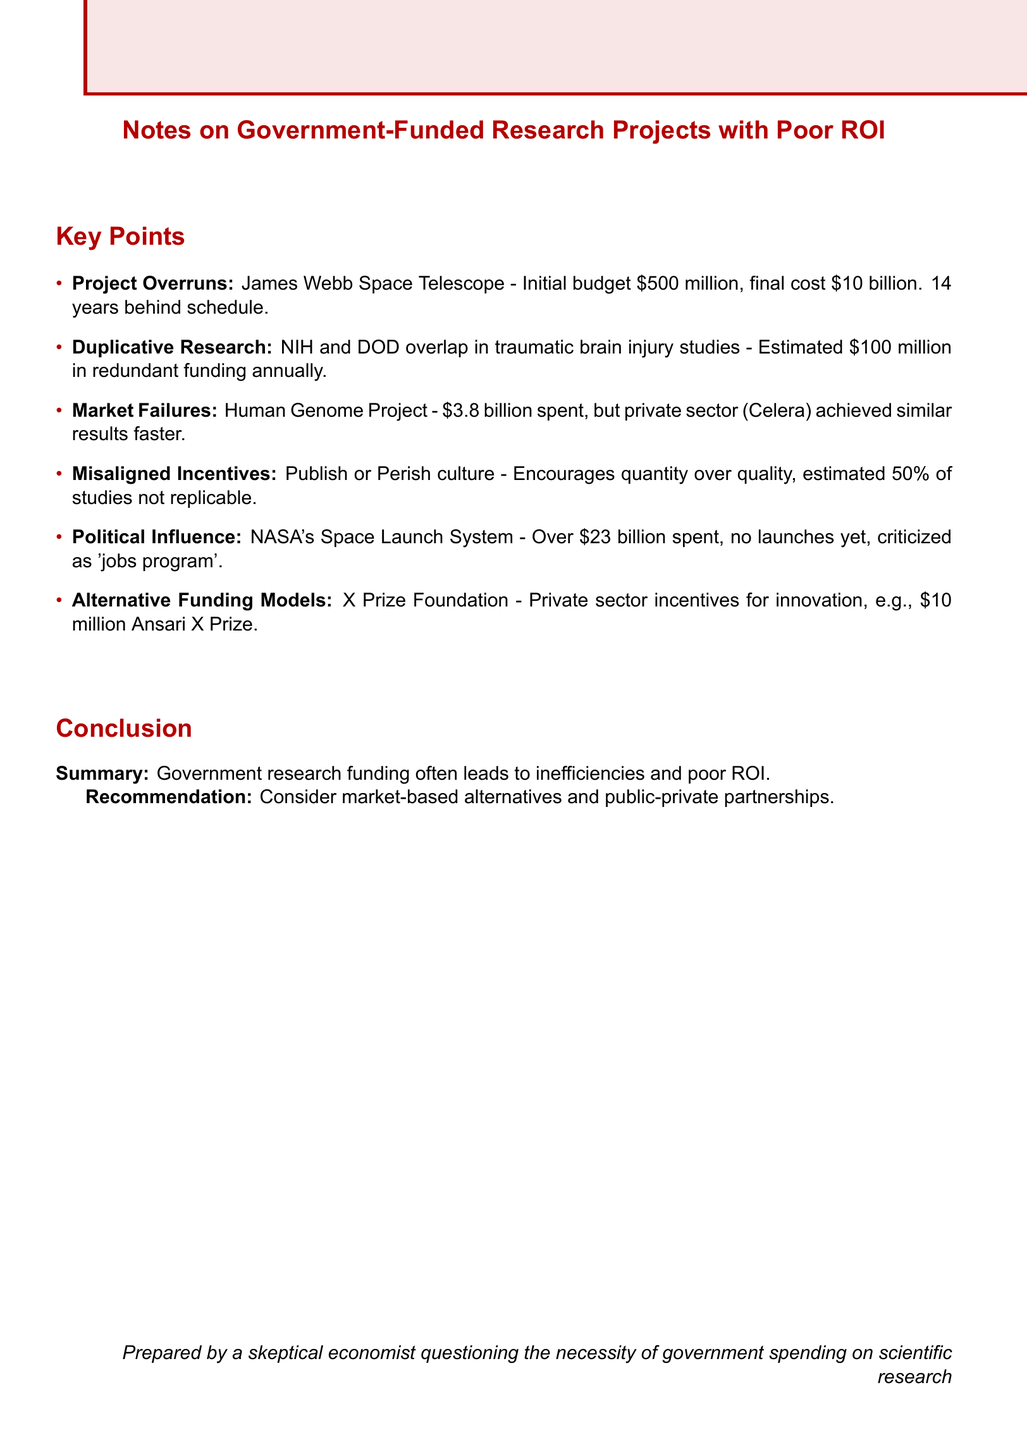What is the initial budget of the James Webb Space Telescope? The initial budget is stated in the document for the James Webb Space Telescope, which is $500 million.
Answer: $500 million How much was the final cost of the James Webb Space Telescope? The document mentions the final cost of the James Webb Space Telescope as $10 billion.
Answer: $10 billion What is the estimated annual redundant funding in traumatic brain injury studies? The estimated redundant funding annually is provided in the document, which is $100 million.
Answer: $100 million How much was spent on the Human Genome Project? The document states that $3.8 billion was spent on the Human Genome Project.
Answer: $3.8 billion What is the total amount spent on NASA's Space Launch System? The document explicitly states that over $23 billion has been spent on NASA's Space Launch System.
Answer: Over $23 billion What percentage of studies are estimated to be not replicable? The document discusses the Publish or Perish culture and estimates that 50% of studies are not replicable.
Answer: 50% What is the recommendation given in the conclusion? The conclusion recommends considering market-based alternatives and public-private partnerships.
Answer: Consider market-based alternatives and public-private partnerships Which organization is mentioned as an alternative funding model? The document highlights the X Prize Foundation as an example of an alternative funding model.
Answer: X Prize Foundation What term is used to describe the culture that encourages quantity over quality in research? The document uses the term “Publish or Perish” to describe this culture.
Answer: Publish or Perish 